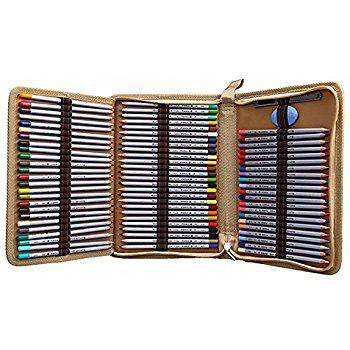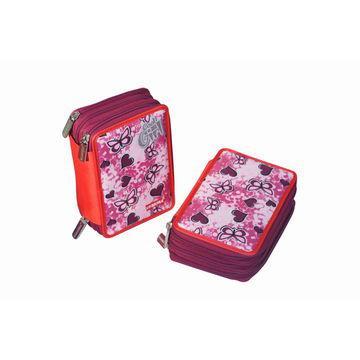The first image is the image on the left, the second image is the image on the right. Evaluate the accuracy of this statement regarding the images: "An image features a bright pink case that is fanned open to reveal multiple sections holding a variety of writing implements.". Is it true? Answer yes or no. No. The first image is the image on the left, the second image is the image on the right. Considering the images on both sides, is "There are exactly three pencil cases." valid? Answer yes or no. Yes. 